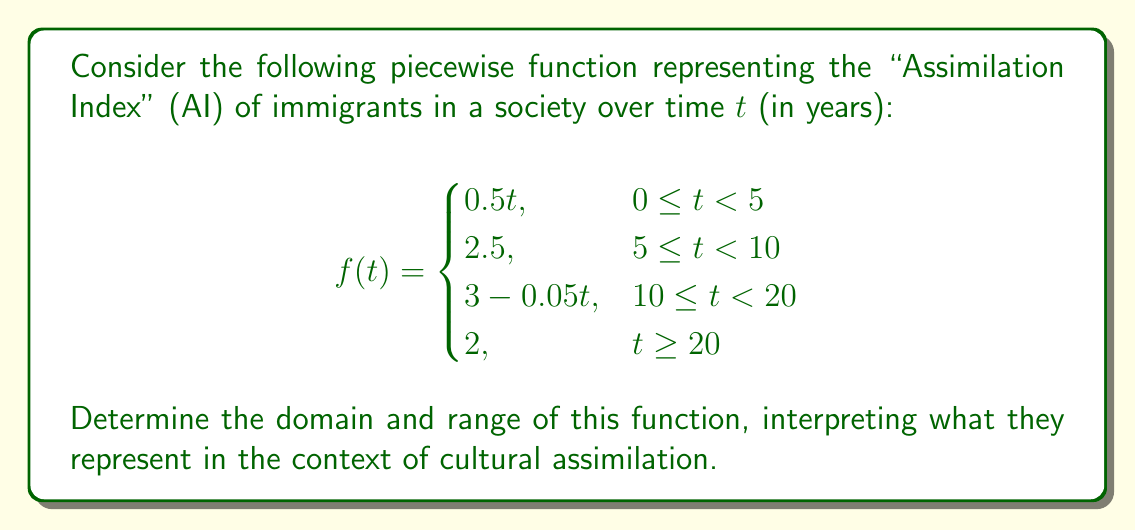Solve this math problem. To find the domain and range of this piecewise function, we need to analyze each piece:

1. Domain:
   The function is defined for all non-negative real numbers, as time cannot be negative. Each piece of the function covers a specific interval of time, and together they cover all non-negative real numbers. Therefore, the domain is $[0, \infty)$.

2. Range:
   We need to consider the minimum and maximum values of each piece:

   a) For $0 \leq t < 5$: 
      $f(t) = 0.5t$
      Minimum value: $f(0) = 0$
      Maximum value: $f(5^-) = 2.5$

   b) For $5 \leq t < 10$:
      $f(t) = 2.5$ (constant)

   c) For $10 \leq t < 20$:
      $f(t) = 3 - 0.05t$
      Minimum value: $f(20^-) = 2$
      Maximum value: $f(10) = 2.5$

   d) For $t \geq 20$:
      $f(t) = 2$ (constant)

   The overall minimum value is 0, and the overall maximum value is 2.5.
   Therefore, the range is $[0, 2.5]$.

Interpretation:
The domain $[0, \infty)$ represents that the Assimilation Index is measured from the moment immigrants arrive (t = 0) and continues indefinitely.

The range $[0, 2.5]$ indicates that the Assimilation Index varies between 0 (no assimilation) and 2.5 (maximum assimilation achieved in this model). This suggests that even with time, there's a limit to how much immigrants assimilate into the host society according to this controversial model.
Answer: Domain: $[0, \infty)$
Range: $[0, 2.5]$ 